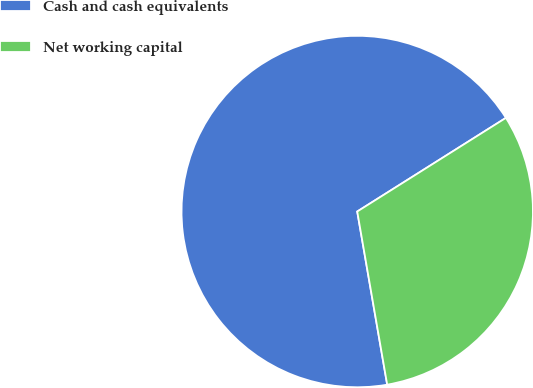Convert chart to OTSL. <chart><loc_0><loc_0><loc_500><loc_500><pie_chart><fcel>Cash and cash equivalents<fcel>Net working capital<nl><fcel>68.78%<fcel>31.22%<nl></chart> 